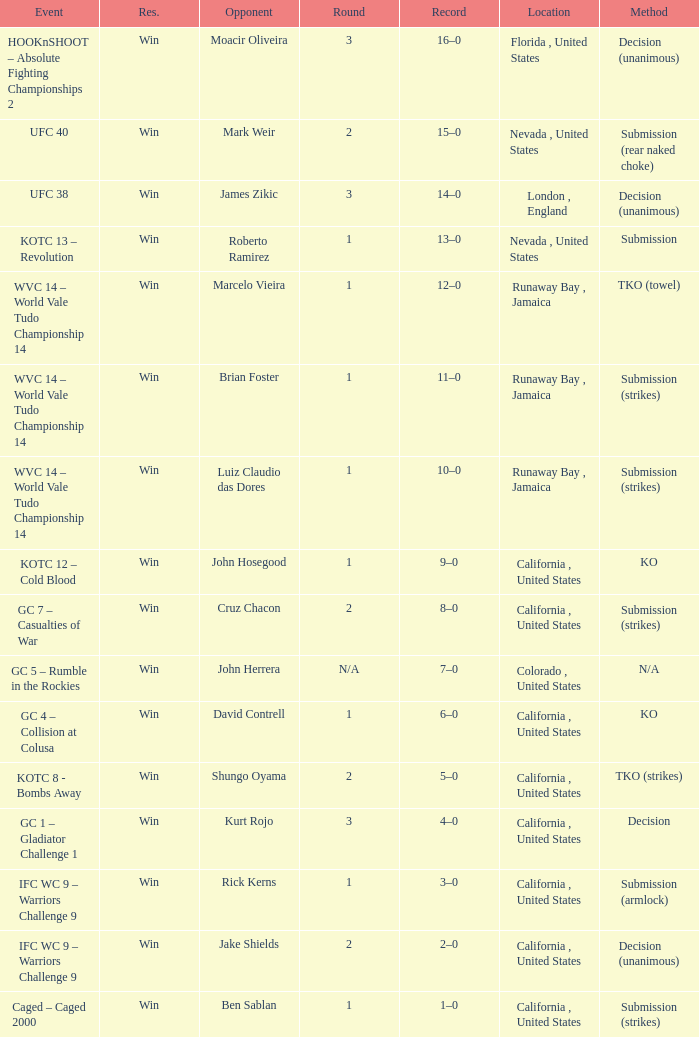Where was the fight located that lasted 1 round against luiz claudio das dores? Runaway Bay , Jamaica. 